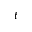Convert formula to latex. <formula><loc_0><loc_0><loc_500><loc_500>t</formula> 